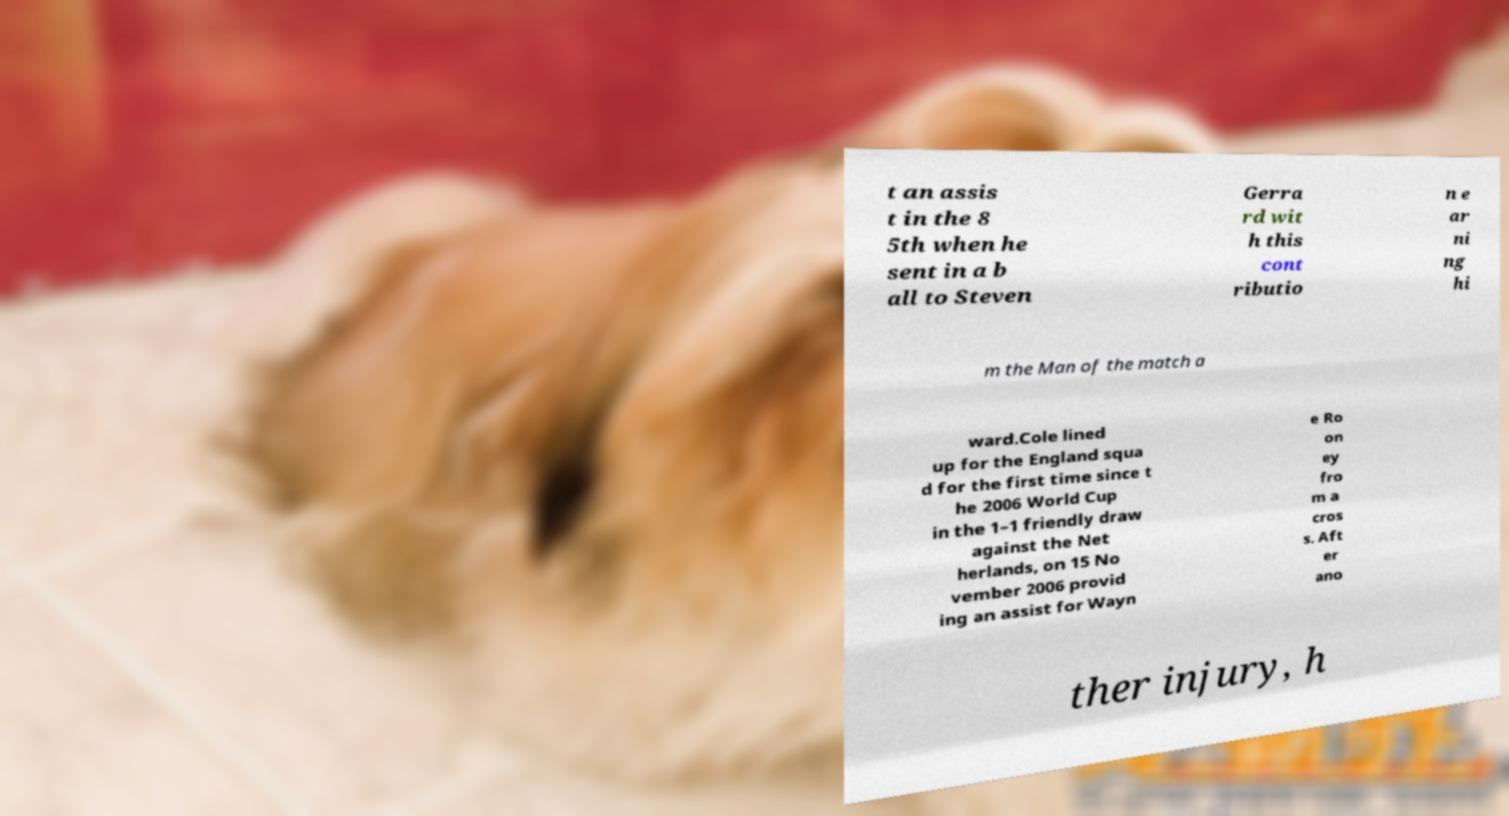Could you assist in decoding the text presented in this image and type it out clearly? t an assis t in the 8 5th when he sent in a b all to Steven Gerra rd wit h this cont ributio n e ar ni ng hi m the Man of the match a ward.Cole lined up for the England squa d for the first time since t he 2006 World Cup in the 1–1 friendly draw against the Net herlands, on 15 No vember 2006 provid ing an assist for Wayn e Ro on ey fro m a cros s. Aft er ano ther injury, h 